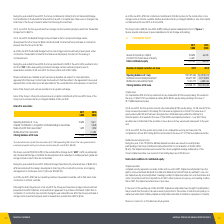From National Storage Reit's financial document, What was the share of profit from associates representing NSRs in 2019 and 2018? The document shows two values: $1,917,000 and $1,383,000. From the document: "ld by joint ventures and associates (30 June 2018: $1,383,000). The Group owns 24.9% (2018: 24.9%) of the Australia Prime Storage Fund (“ APSF ”). APS..." Also, What percentage does the Group own of the Australian Prime Storage Fund in 2018? According to the financial document, 24.9%. The relevant text states: "ociates (30 June 2018: $1,383,000). The Group owns 24.9% (2018: 24.9%) of the Australia Prime Storage Fund (“ APSF ”). APSF is a partnership with Universal S ociates (30 June 2018: $1,383,000). The Gr..." Also, What was the Capital contribution / acquisition of shareholding in associates in 2018? According to the financial document, 2,048 (in thousands). The relevant text states: "ion / acquisition of shareholding in associates - 2,048..." Also, can you calculate: What was the average Capital contribution / acquisition of shareholding in associates for 2018 and 2019? To answer this question, I need to perform calculations using the financial data. The calculation is: (0 + 2,048) / 2, which equals 1024 (in thousands). This is based on the information: "ion / acquisition of shareholding in associates - 2,048 ion / acquisition of shareholding in associates - 2,048..." The key data points involved are: 2,048. Also, can you calculate: What is the change in the Share of profit from associates from 2018 to 2019? Based on the calculation: 1,695 - 1,282, the result is 413 (in thousands). This is based on the information: "Share of profit from associates* 1,695 1,282 Share of profit from associates* 1,695 1,282..." The key data points involved are: 1,282, 1,695. Additionally, In which year was the Closing balance at 30 June less than 11,000 thousands? According to the financial document, 2018. The relevant text states: "Number of stapled securities on Issue 2019 2018..." 